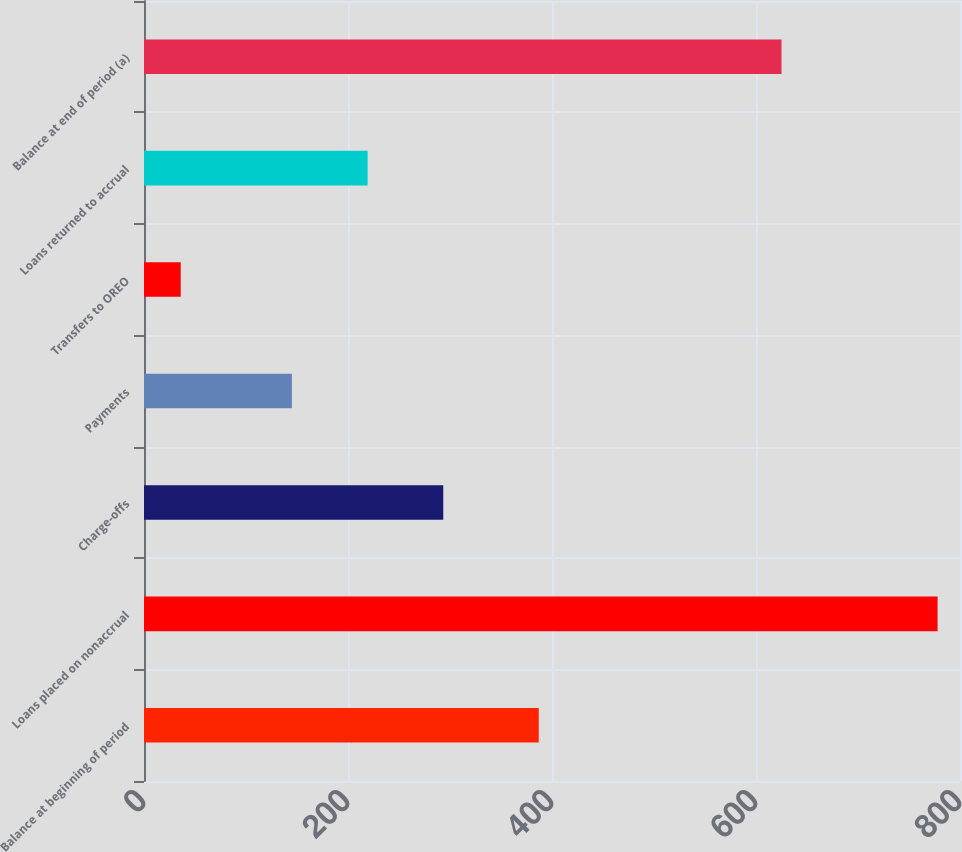Convert chart to OTSL. <chart><loc_0><loc_0><loc_500><loc_500><bar_chart><fcel>Balance at beginning of period<fcel>Loans placed on nonaccrual<fcel>Charge-offs<fcel>Payments<fcel>Transfers to OREO<fcel>Loans returned to accrual<fcel>Balance at end of period (a)<nl><fcel>387<fcel>778<fcel>293.4<fcel>145<fcel>36<fcel>219.2<fcel>625<nl></chart> 